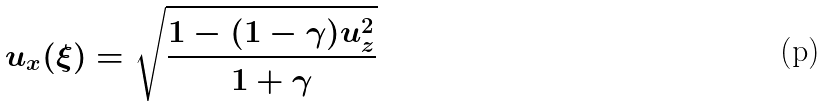<formula> <loc_0><loc_0><loc_500><loc_500>u _ { x } ( \xi ) = \sqrt { \frac { 1 - ( 1 - \gamma ) u _ { z } ^ { 2 } } { 1 + \gamma } }</formula> 